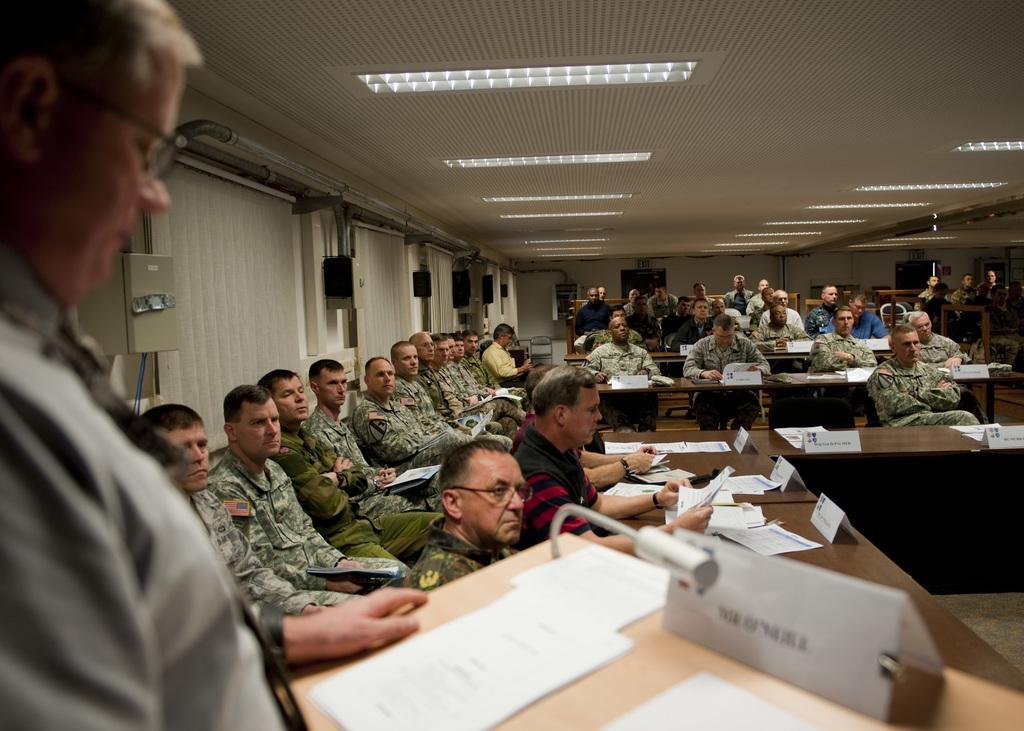In one or two sentences, can you explain what this image depicts? In this picture we can observe some soldiers sitting in the chairs. There are some people sitting in front of the tables on which we can observe name boards and some papers. On the left side there is a person standing in front of a podium. We can observe some lights in the ceiling. In the background there is a wall. 